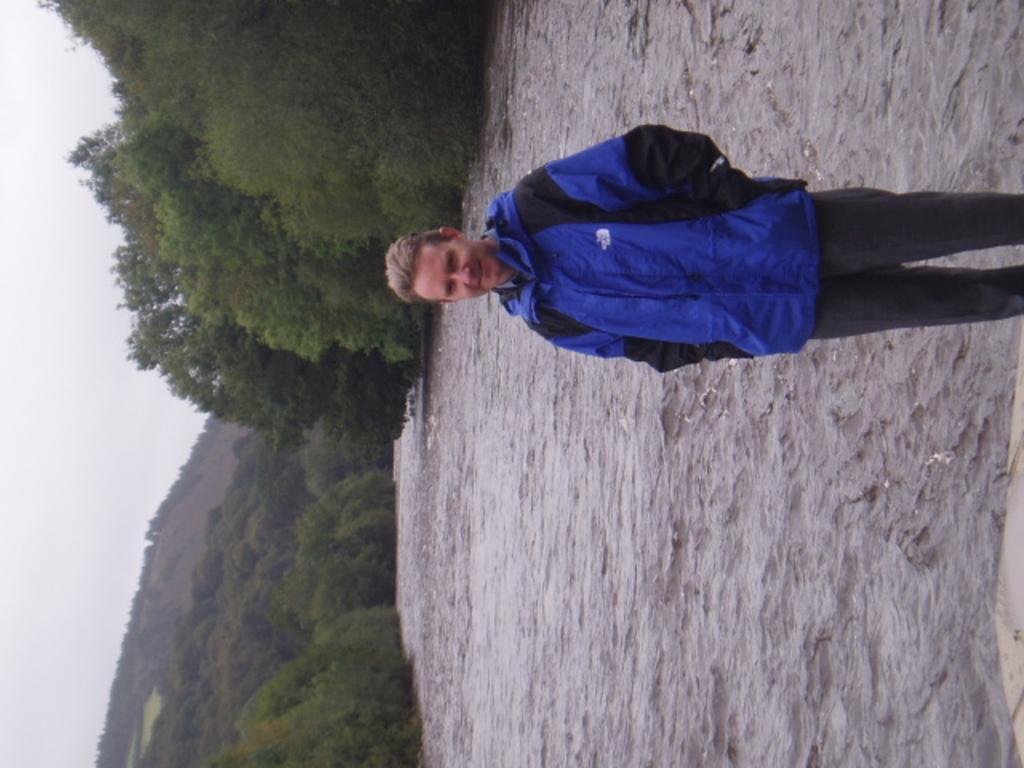How would you summarize this image in a sentence or two? In this image we can see a person. There are many trees in the image. We can see the lake in the image. We can see the sky in the image. There is a hill in the image. 